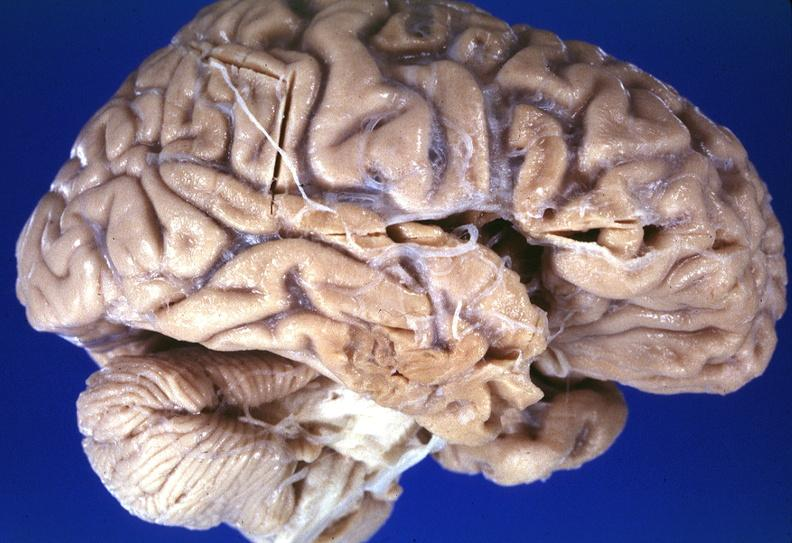s nervous present?
Answer the question using a single word or phrase. Yes 